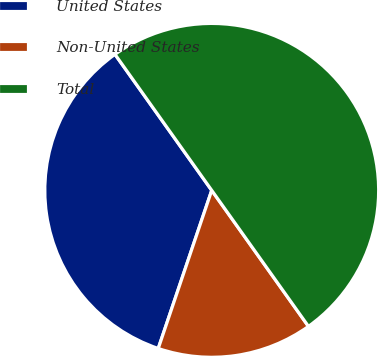Convert chart. <chart><loc_0><loc_0><loc_500><loc_500><pie_chart><fcel>United States<fcel>Non-United States<fcel>Total<nl><fcel>34.97%<fcel>15.03%<fcel>50.0%<nl></chart> 